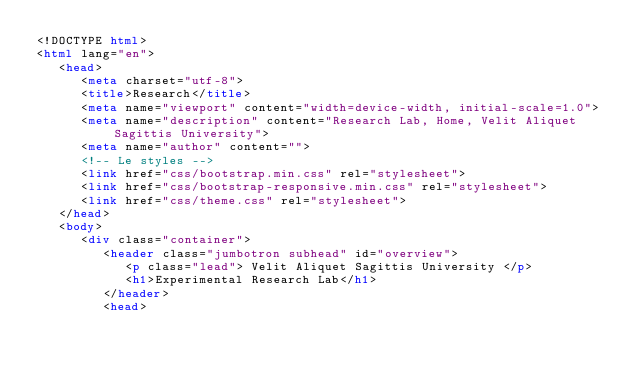<code> <loc_0><loc_0><loc_500><loc_500><_HTML_><!DOCTYPE html>
<html lang="en">
   <head>
      <meta charset="utf-8">
      <title>Research</title>
      <meta name="viewport" content="width=device-width, initial-scale=1.0">
      <meta name="description" content="Research Lab, Home, Velit Aliquet Sagittis University">
      <meta name="author" content="">
      <!-- Le styles -->
      <link href="css/bootstrap.min.css" rel="stylesheet">
      <link href="css/bootstrap-responsive.min.css" rel="stylesheet">
      <link href="css/theme.css" rel="stylesheet">
   </head>
   <body>
      <div class="container">
         <header class="jumbotron subhead" id="overview">
            <p class="lead"> Velit Aliquet Sagittis University </p>
            <h1>Experimental Research Lab</h1>
         </header>
         <head></code> 